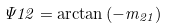Convert formula to latex. <formula><loc_0><loc_0><loc_500><loc_500>\Psi 1 2 = \arctan { ( - m _ { 2 1 } ) }</formula> 